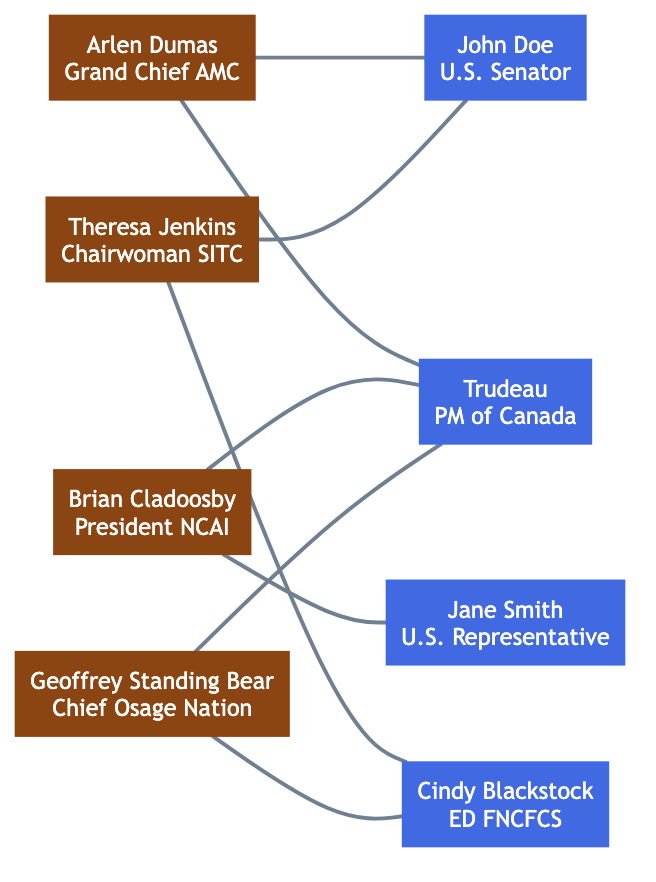What is the total number of nodes in the diagram? To find the total number of nodes, I count all unique nodes listed in the "nodes" section. There are 4 tribal leaders and 4 national politicians, therefore the total is 4 + 4 = 8.
Answer: 8 Which tribal leader is connected to the U.S. Senator? I look at the connections in the "edges" section. I see that both Arlen Dumas and Theresa Jenkins have edges connecting to the U.S. Senator, which is John Doe.
Answer: Arlen Dumas, Theresa Jenkins How many edges connect tribal leaders to national politicians? To determine the number of edges, I count each line connecting tribal leaders to national politicians in the "edges" section. There are 8 connections in total.
Answer: 8 Which national politician has the most connections to tribal leaders? I check the connections for each national politician by examining the edges. Trudeau and Cindy Blackstock each have 3 connections. Therefore, both have the most connections.
Answer: Trudeau, Cindy Blackstock Do any tribal leaders connect to more than one national politician? I analyze the edges for each tribal leader. Arlen Dumas connects to John Doe and Trudeau, Brian Cladoosby connects to Jane Smith and Trudeau, Theresa Jenkins connects to John Doe and Cindy Blackstock, and Geoffrey Standing Bear connects to Trudeau and Cindy Blackstock. Since all tribal leaders connect to multiple politicians, the answer is yes.
Answer: Yes How many national politicians are connected to Geoffrey Standing Bear? I examine the edges connected to Geoffrey Standing Bear. I find two connections: one to Trudeau and one to Cindy Blackstock.
Answer: 2 Which tribal leader has the least number of connections? I assess the connections for each tribal leader: Arlen Dumas has 2, Brian Cladoosby has 2, Theresa Jenkins has 2, and Geoffrey Standing Bear also has 2. All tribal leaders have the same number of connections, so they are all tied for the least connections.
Answer: All are tied Is there a connection between Theresa Jenkins and any U.S. Senator? I review the edges in the diagram and find that Theresa Jenkins has a connection to John Doe, who is identified as a U.S. Senator.
Answer: Yes 